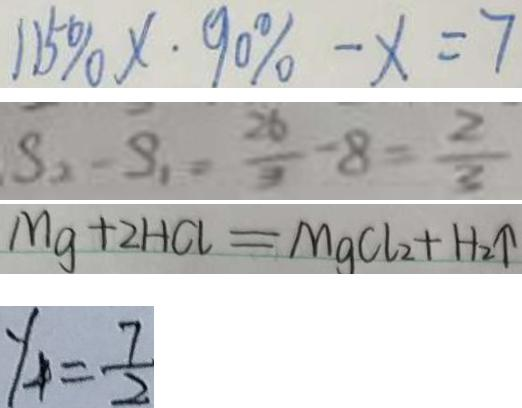Convert formula to latex. <formula><loc_0><loc_0><loc_500><loc_500>1 1 5 \% x \cdot 9 0 \% - x = 7 
 S _ { 2 } - S _ { 1 } = \frac { 2 6 } { 3 } - 8 = \frac { 2 } { 3 } 
 M g + 2 H C l = M g C L _ { 2 } + H _ { 2 } \uparrow 
 y _ { 4 } = \frac { 7 } { 2 }</formula> 